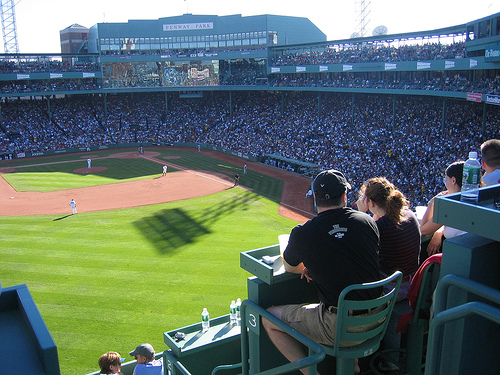<image>
Is there a bottle next to the man? No. The bottle is not positioned next to the man. They are located in different areas of the scene. Is there a seats on the grass? No. The seats is not positioned on the grass. They may be near each other, but the seats is not supported by or resting on top of the grass. Is there a woman to the left of the man? No. The woman is not to the left of the man. From this viewpoint, they have a different horizontal relationship. 